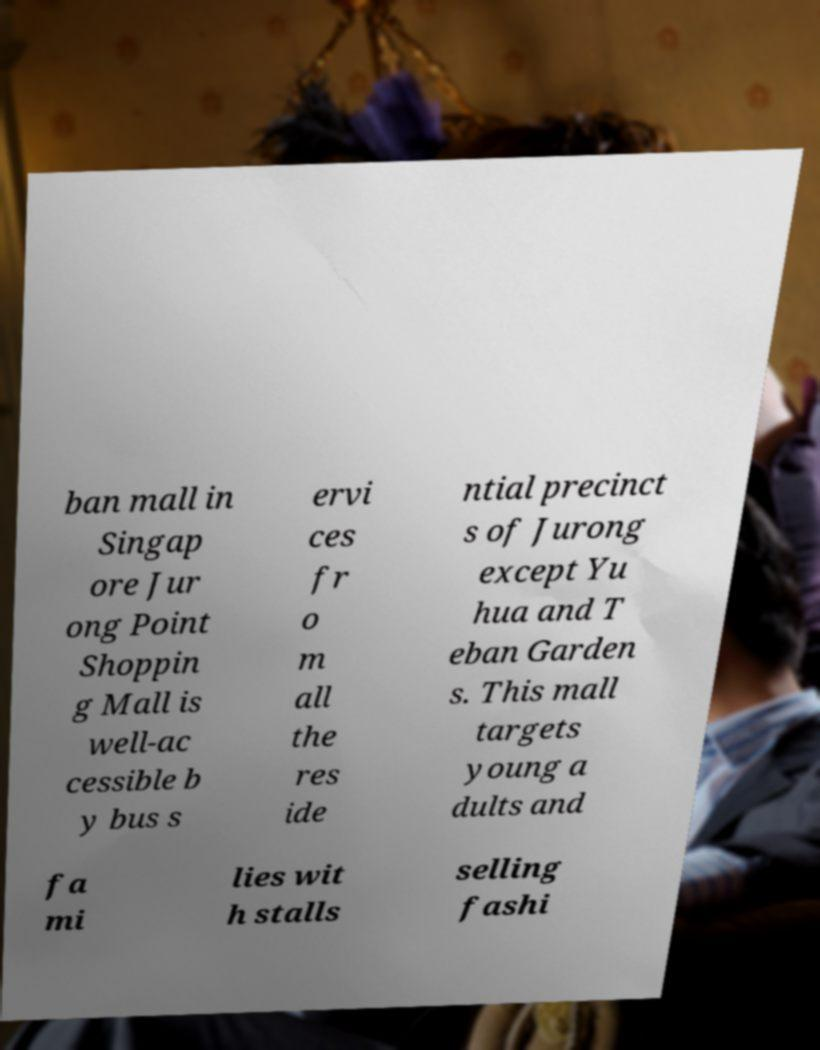Can you read and provide the text displayed in the image?This photo seems to have some interesting text. Can you extract and type it out for me? ban mall in Singap ore Jur ong Point Shoppin g Mall is well-ac cessible b y bus s ervi ces fr o m all the res ide ntial precinct s of Jurong except Yu hua and T eban Garden s. This mall targets young a dults and fa mi lies wit h stalls selling fashi 